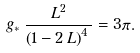<formula> <loc_0><loc_0><loc_500><loc_500>g _ { \ast } \, \frac { L ^ { 2 } } { \left ( 1 - 2 \, L \right ) ^ { 4 } \, } & = 3 \pi .</formula> 